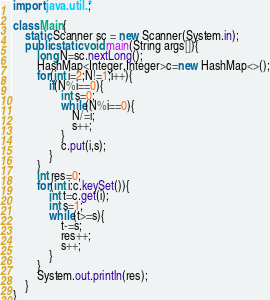Convert code to text. <code><loc_0><loc_0><loc_500><loc_500><_Java_>import java.util.*;

class Main{
    static Scanner sc = new Scanner(System.in);
    public static void main(String args[]){
        long N=sc.nextLong();
        HashMap<Integer,Integer>c=new HashMap<>();
        for(int i=2;N!=1;i++){
            if(N%i==0){
                int s=0;
                while(N%i==0){
                    N/=i;
                    s++;
                }
                c.put(i,s);
            }
        }
        int res=0;
        for(int i:c.keySet()){
            int t=c.get(i);
            int s=1;
            while(t>=s){
                t-=s;
                res++;
                s++;
            }
        }
        System.out.println(res);
    }
}</code> 